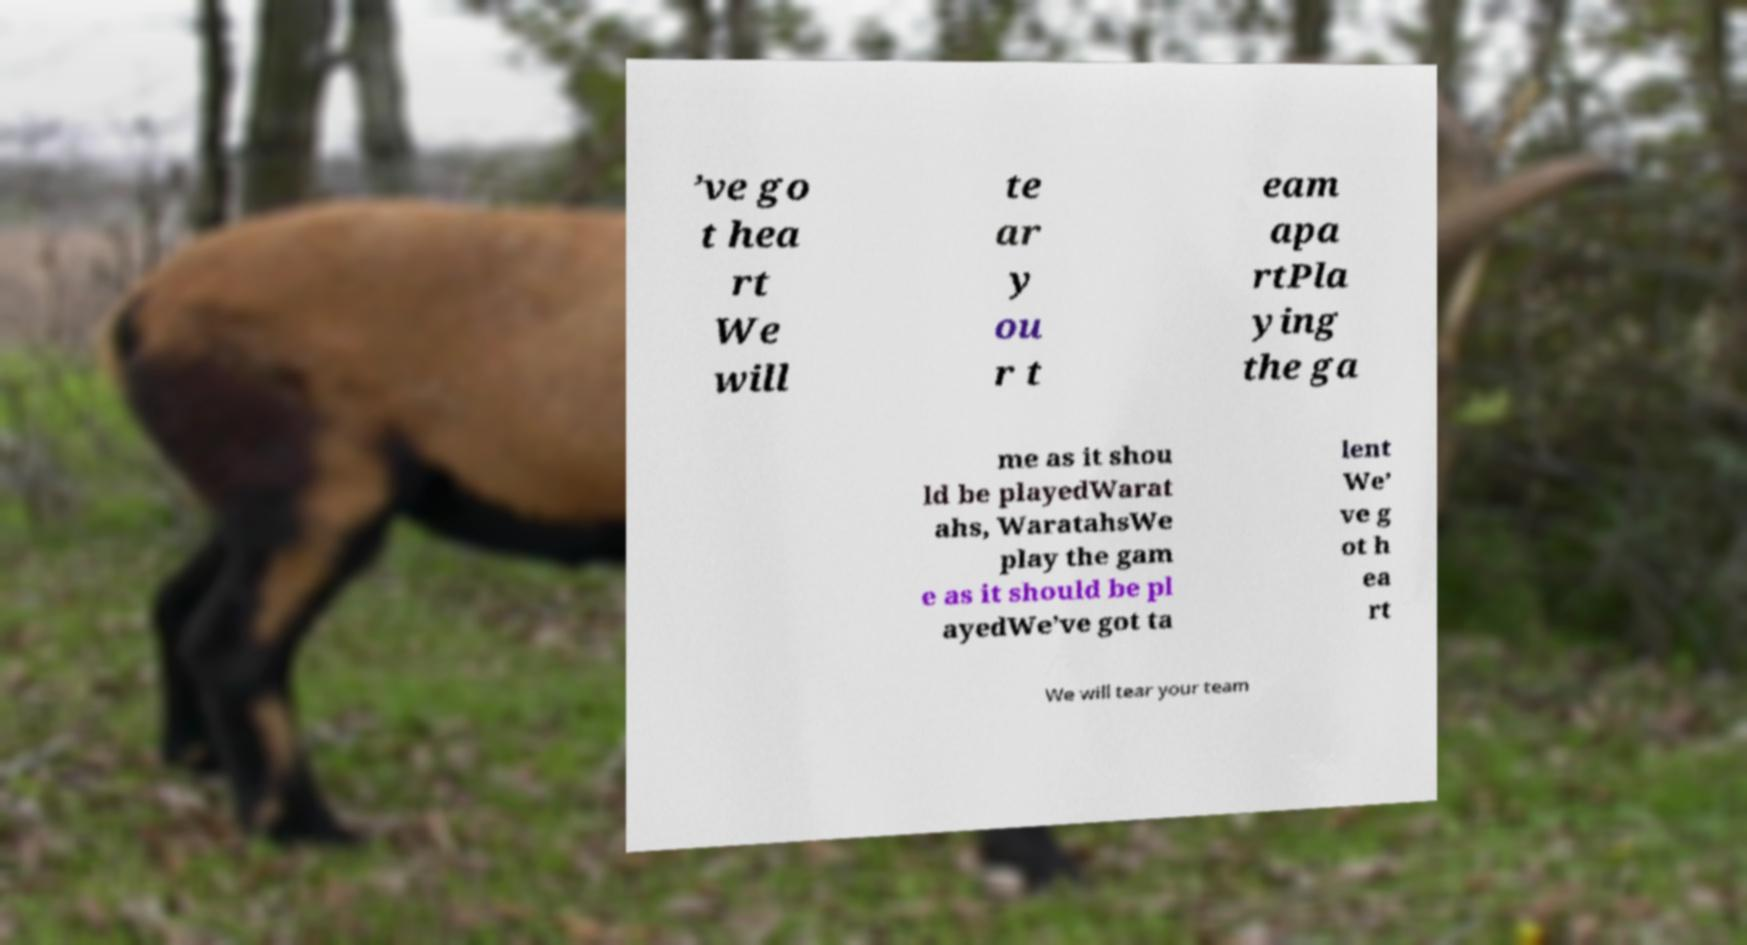Please read and relay the text visible in this image. What does it say? ’ve go t hea rt We will te ar y ou r t eam apa rtPla ying the ga me as it shou ld be playedWarat ahs, WaratahsWe play the gam e as it should be pl ayedWe’ve got ta lent We’ ve g ot h ea rt We will tear your team 